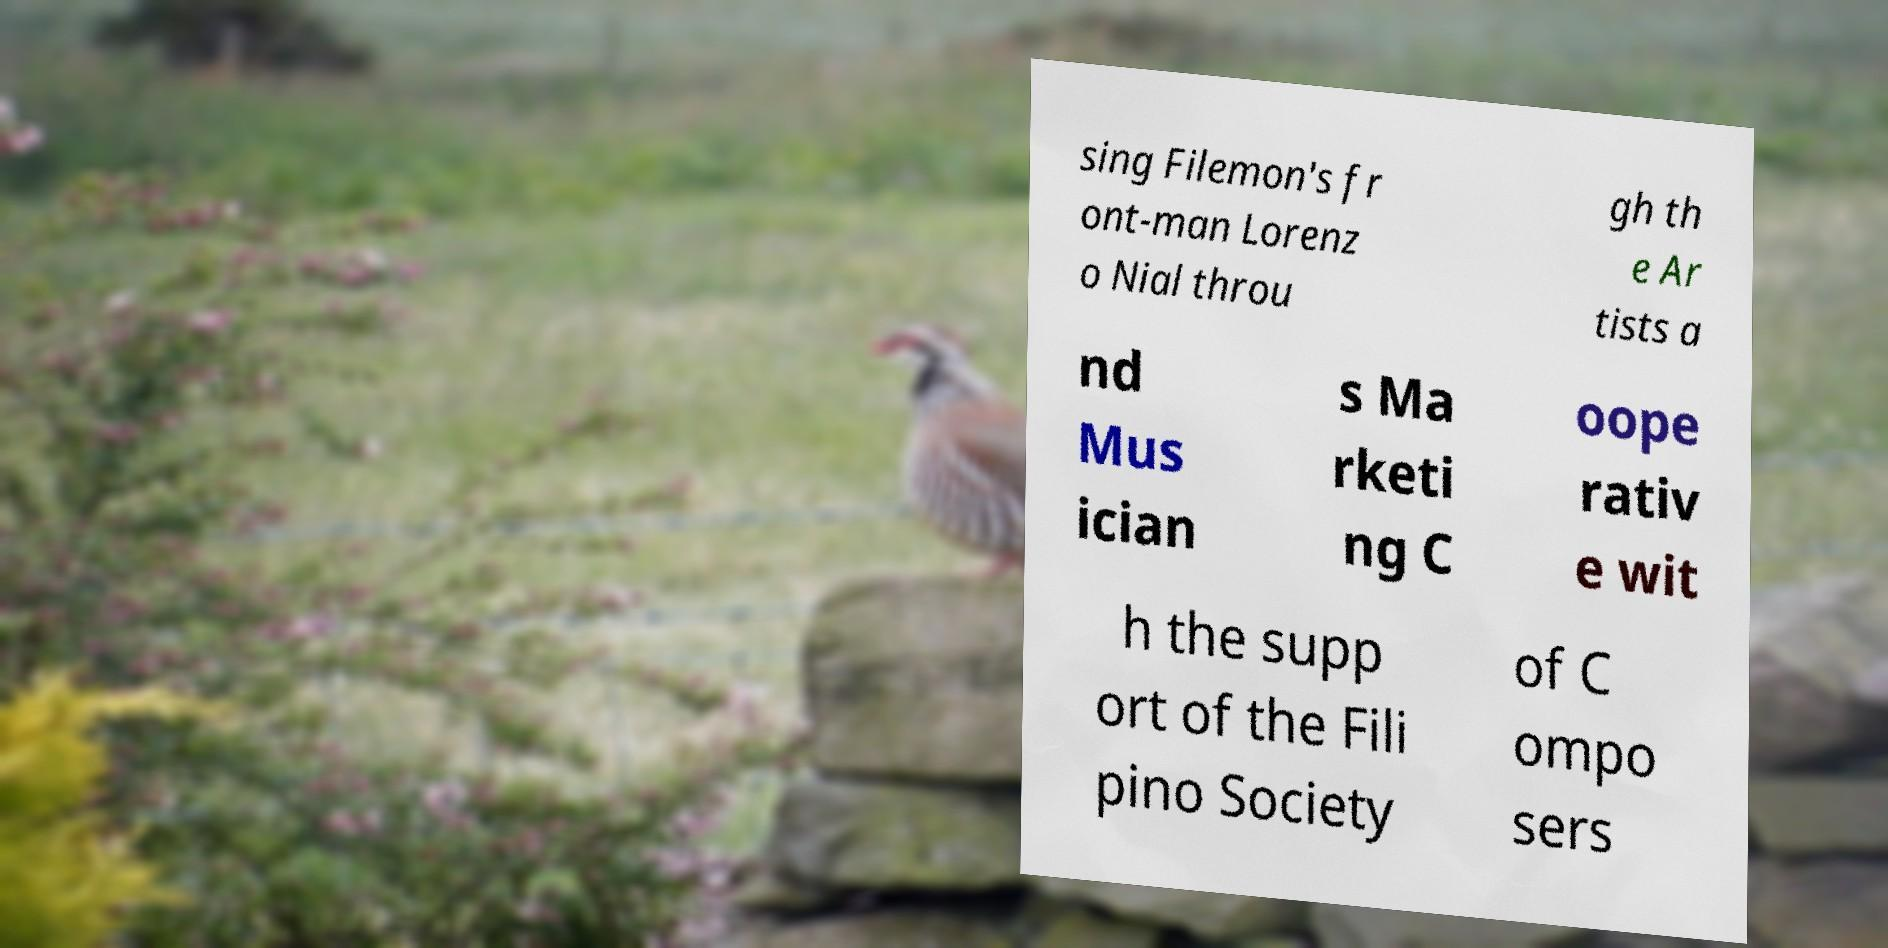Please read and relay the text visible in this image. What does it say? sing Filemon's fr ont-man Lorenz o Nial throu gh th e Ar tists a nd Mus ician s Ma rketi ng C oope rativ e wit h the supp ort of the Fili pino Society of C ompo sers 